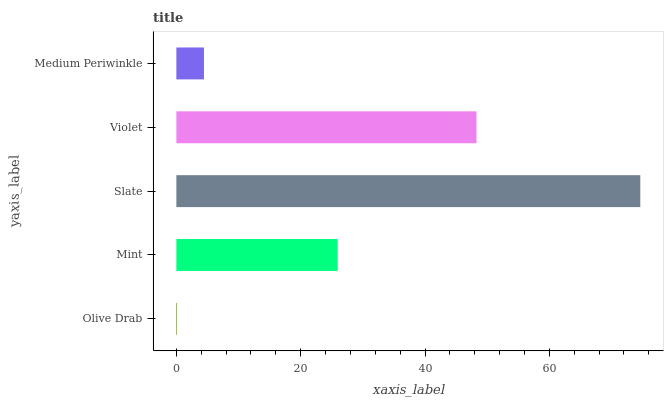Is Olive Drab the minimum?
Answer yes or no. Yes. Is Slate the maximum?
Answer yes or no. Yes. Is Mint the minimum?
Answer yes or no. No. Is Mint the maximum?
Answer yes or no. No. Is Mint greater than Olive Drab?
Answer yes or no. Yes. Is Olive Drab less than Mint?
Answer yes or no. Yes. Is Olive Drab greater than Mint?
Answer yes or no. No. Is Mint less than Olive Drab?
Answer yes or no. No. Is Mint the high median?
Answer yes or no. Yes. Is Mint the low median?
Answer yes or no. Yes. Is Olive Drab the high median?
Answer yes or no. No. Is Medium Periwinkle the low median?
Answer yes or no. No. 